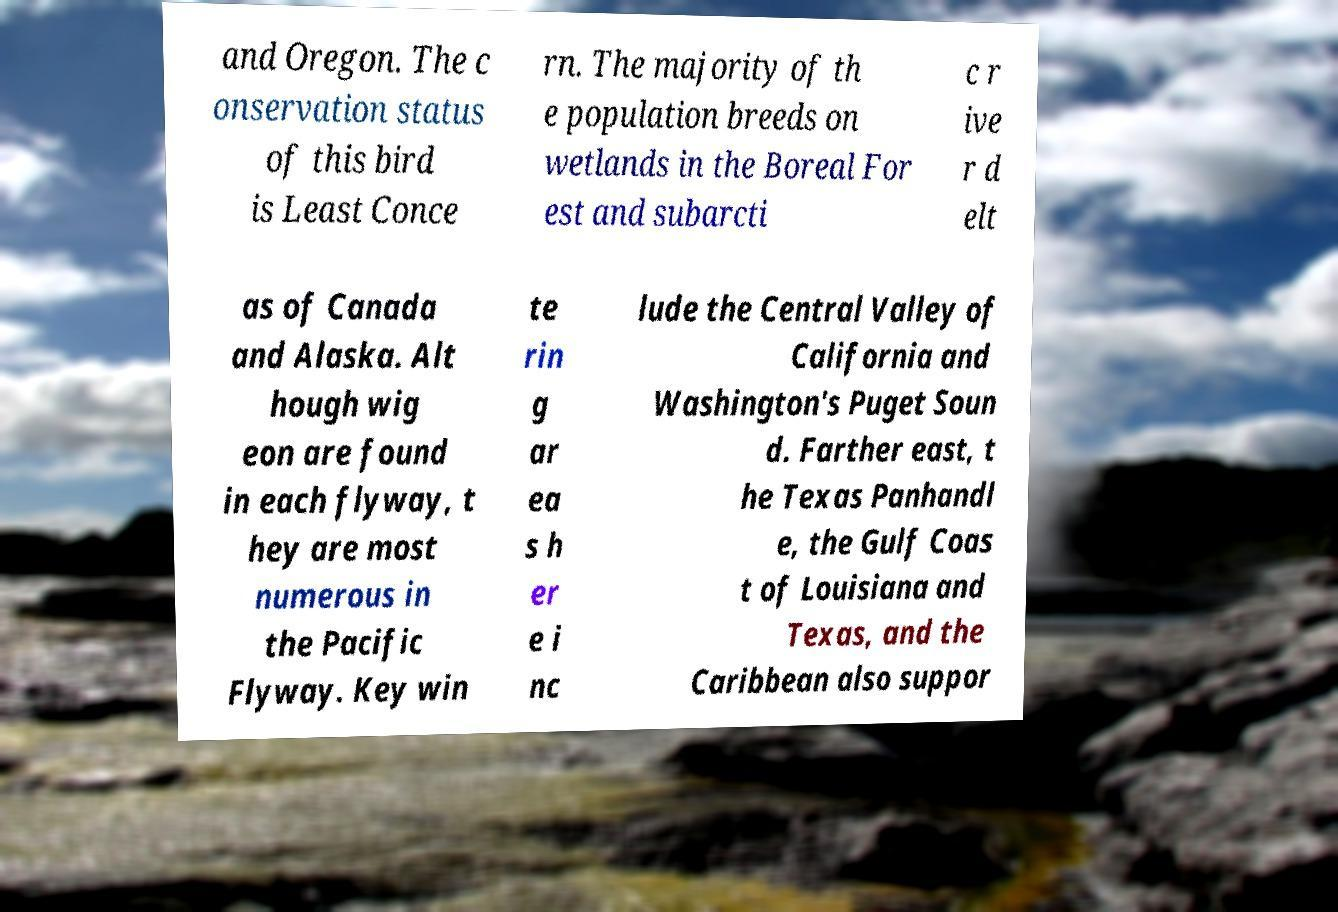Please identify and transcribe the text found in this image. and Oregon. The c onservation status of this bird is Least Conce rn. The majority of th e population breeds on wetlands in the Boreal For est and subarcti c r ive r d elt as of Canada and Alaska. Alt hough wig eon are found in each flyway, t hey are most numerous in the Pacific Flyway. Key win te rin g ar ea s h er e i nc lude the Central Valley of California and Washington's Puget Soun d. Farther east, t he Texas Panhandl e, the Gulf Coas t of Louisiana and Texas, and the Caribbean also suppor 